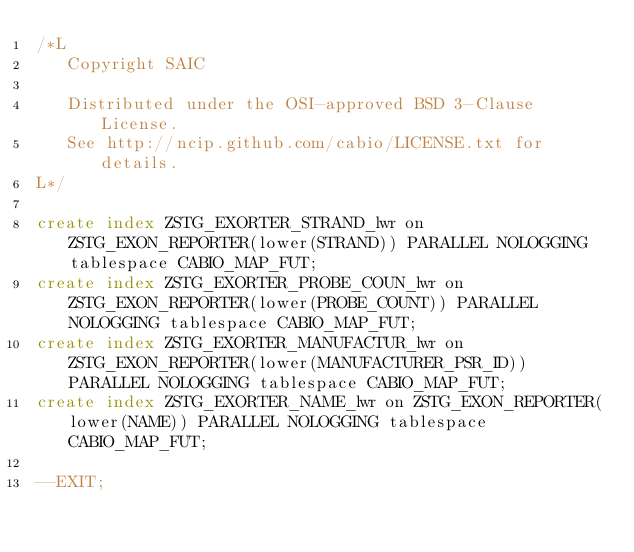Convert code to text. <code><loc_0><loc_0><loc_500><loc_500><_SQL_>/*L
   Copyright SAIC

   Distributed under the OSI-approved BSD 3-Clause License.
   See http://ncip.github.com/cabio/LICENSE.txt for details.
L*/

create index ZSTG_EXORTER_STRAND_lwr on ZSTG_EXON_REPORTER(lower(STRAND)) PARALLEL NOLOGGING tablespace CABIO_MAP_FUT;
create index ZSTG_EXORTER_PROBE_COUN_lwr on ZSTG_EXON_REPORTER(lower(PROBE_COUNT)) PARALLEL NOLOGGING tablespace CABIO_MAP_FUT;
create index ZSTG_EXORTER_MANUFACTUR_lwr on ZSTG_EXON_REPORTER(lower(MANUFACTURER_PSR_ID)) PARALLEL NOLOGGING tablespace CABIO_MAP_FUT;
create index ZSTG_EXORTER_NAME_lwr on ZSTG_EXON_REPORTER(lower(NAME)) PARALLEL NOLOGGING tablespace CABIO_MAP_FUT;

--EXIT;
</code> 